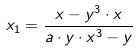Convert formula to latex. <formula><loc_0><loc_0><loc_500><loc_500>x _ { 1 } = \frac { x - y ^ { 3 } \cdot x } { a \cdot y \cdot x ^ { 3 } - y }</formula> 